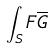<formula> <loc_0><loc_0><loc_500><loc_500>\int _ { S } F \overline { G }</formula> 